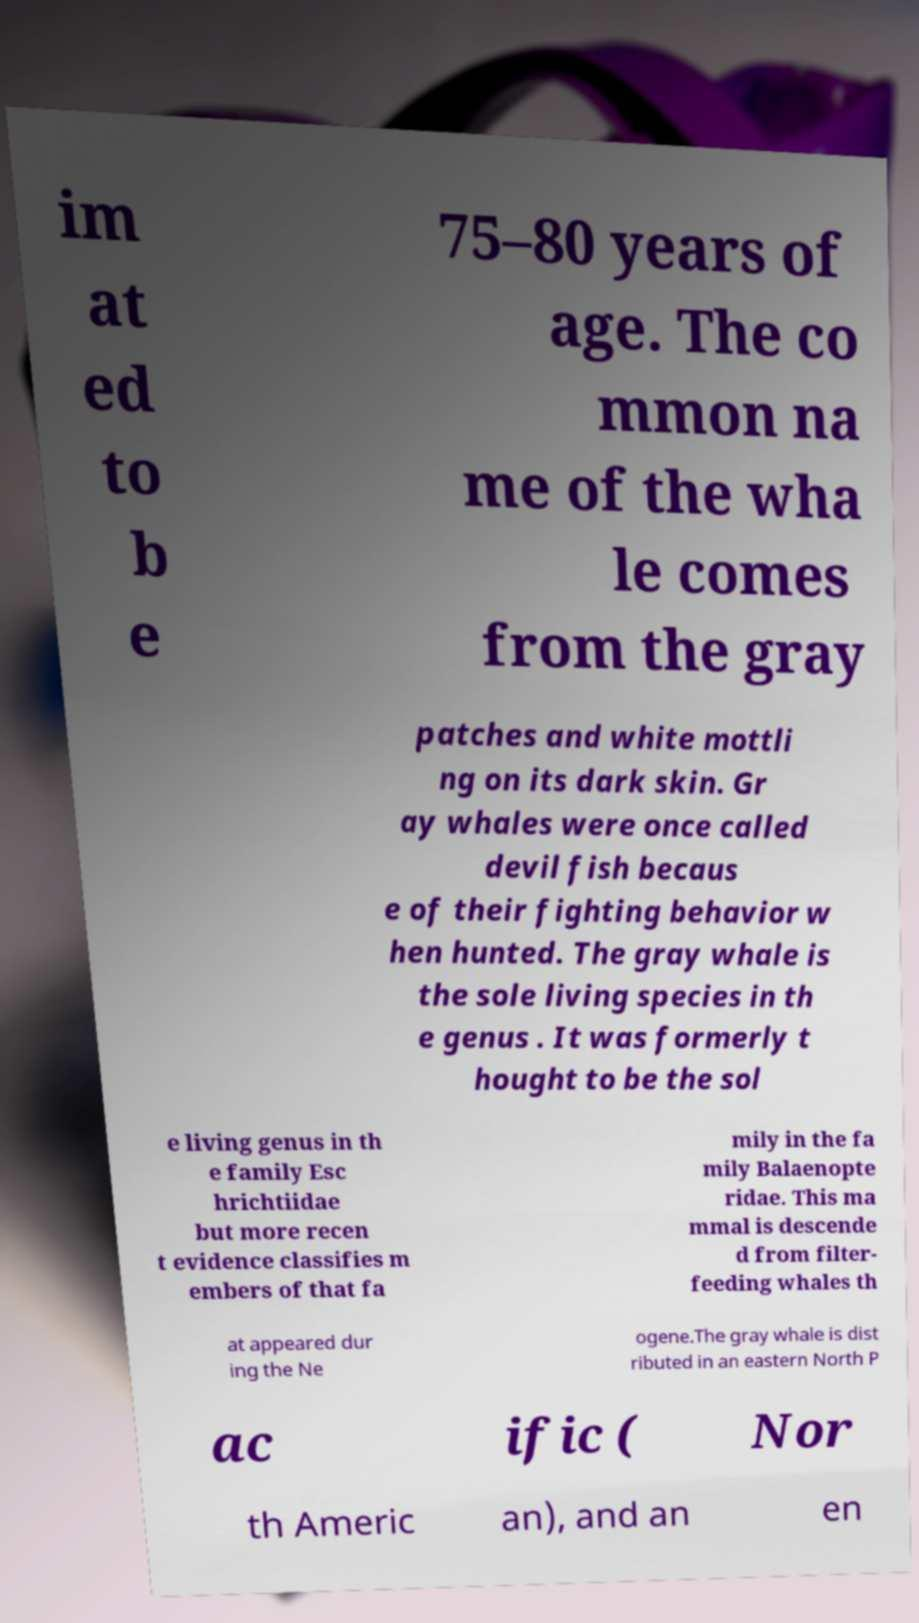I need the written content from this picture converted into text. Can you do that? im at ed to b e 75–80 years of age. The co mmon na me of the wha le comes from the gray patches and white mottli ng on its dark skin. Gr ay whales were once called devil fish becaus e of their fighting behavior w hen hunted. The gray whale is the sole living species in th e genus . It was formerly t hought to be the sol e living genus in th e family Esc hrichtiidae but more recen t evidence classifies m embers of that fa mily in the fa mily Balaenopte ridae. This ma mmal is descende d from filter- feeding whales th at appeared dur ing the Ne ogene.The gray whale is dist ributed in an eastern North P ac ific ( Nor th Americ an), and an en 